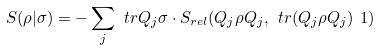<formula> <loc_0><loc_0><loc_500><loc_500>S ( \rho | \sigma ) = - \sum _ { j } \ t r Q _ { j } \sigma \cdot S _ { r e l } ( Q _ { j } \rho Q _ { j } , \ t r ( Q _ { j } \rho Q _ { j } ) \ 1 )</formula> 